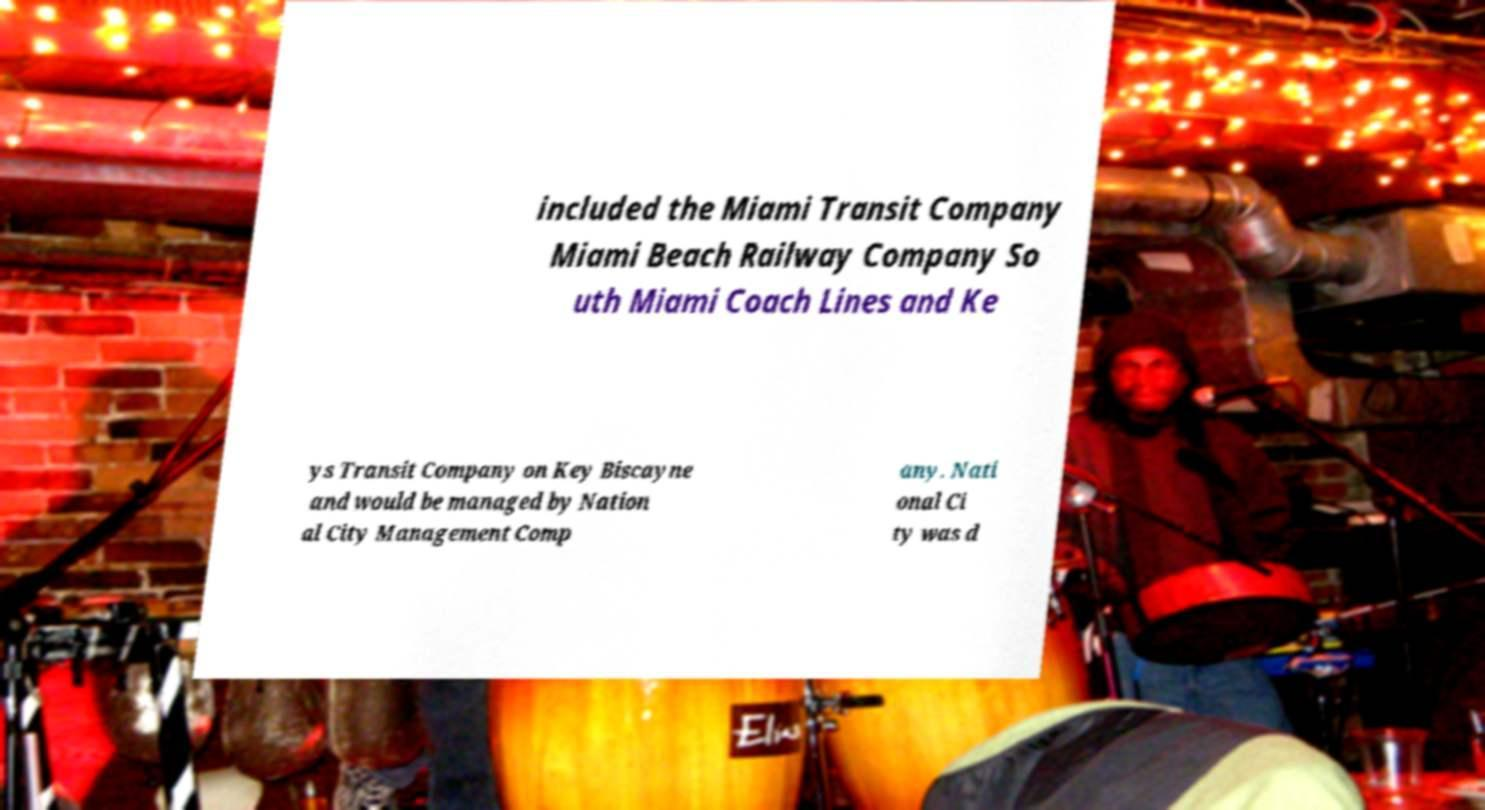Can you accurately transcribe the text from the provided image for me? included the Miami Transit Company Miami Beach Railway Company So uth Miami Coach Lines and Ke ys Transit Company on Key Biscayne and would be managed by Nation al City Management Comp any. Nati onal Ci ty was d 